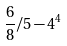Convert formula to latex. <formula><loc_0><loc_0><loc_500><loc_500>\frac { 6 } { 8 } / 5 - 4 ^ { 4 }</formula> 